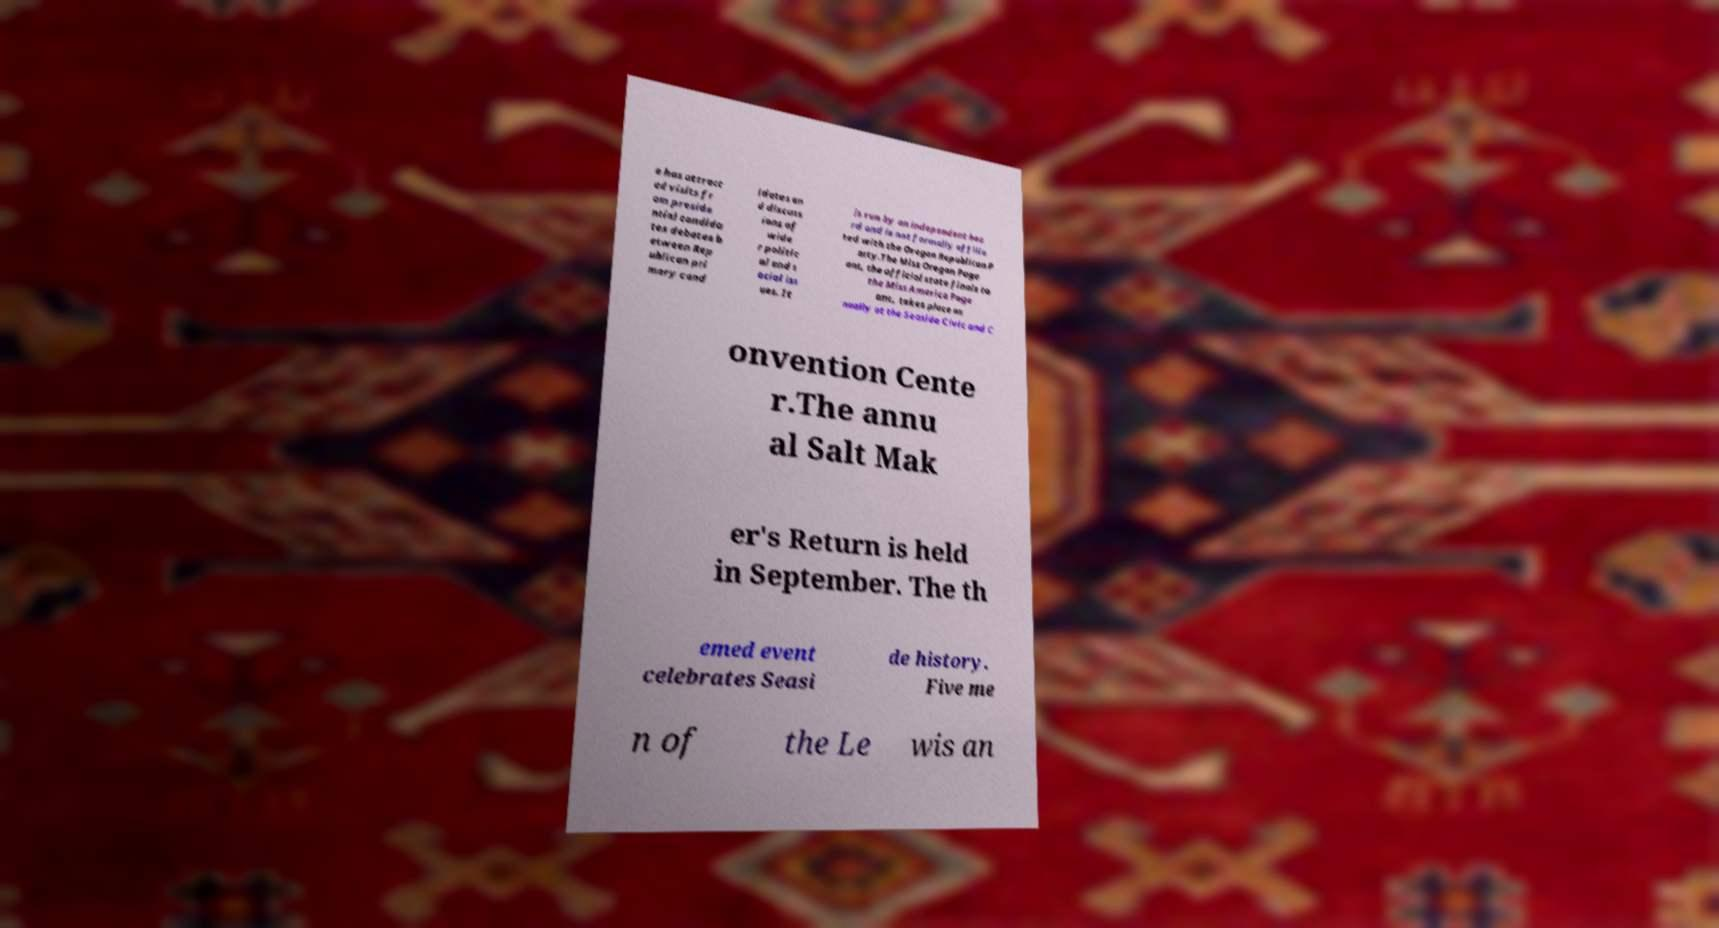Can you accurately transcribe the text from the provided image for me? e has attract ed visits fr om preside ntial candida tes debates b etween Rep ublican pri mary cand idates an d discuss ions of wide r politic al and s ocial iss ues. It is run by an independent boa rd and is not formally affilia ted with the Oregon Republican P arty.The Miss Oregon Page ant, the official state finals to the Miss America Page ant, takes place an nually at the Seaside Civic and C onvention Cente r.The annu al Salt Mak er's Return is held in September. The th emed event celebrates Seasi de history. Five me n of the Le wis an 